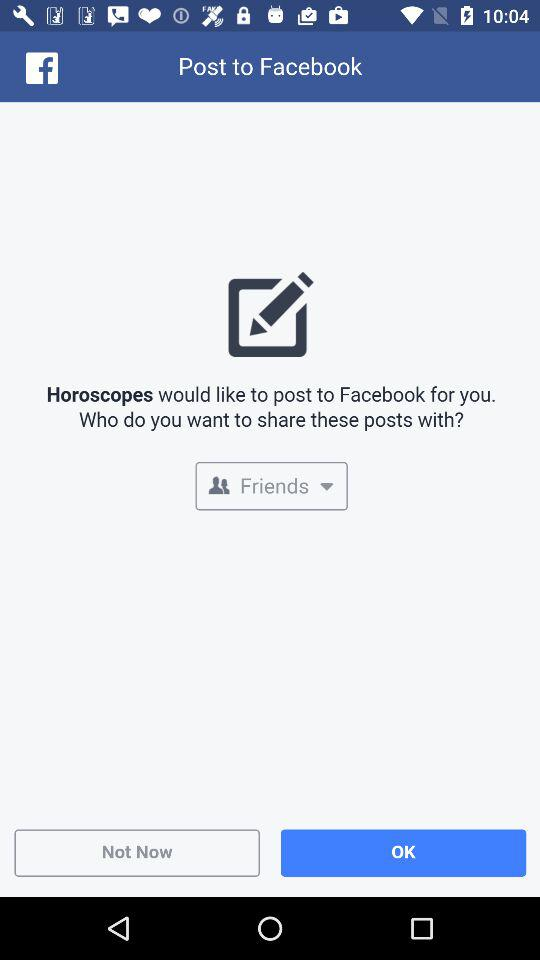What application would like to post to "Facebook"? The application "Horoscopes" would like to post to "Facebook". 